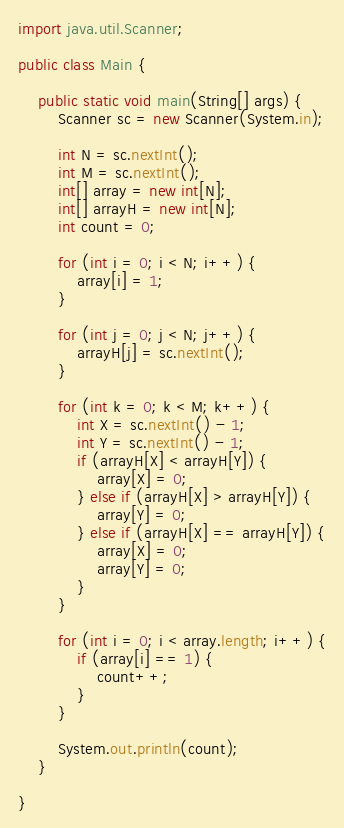<code> <loc_0><loc_0><loc_500><loc_500><_Java_>import java.util.Scanner;

public class Main {

	public static void main(String[] args) {
		Scanner sc = new Scanner(System.in);

		int N = sc.nextInt();
		int M = sc.nextInt();
		int[] array = new int[N];
		int[] arrayH = new int[N];
		int count = 0;

		for (int i = 0; i < N; i++) {
			array[i] = 1;
		}

		for (int j = 0; j < N; j++) {
			arrayH[j] = sc.nextInt();
		}

		for (int k = 0; k < M; k++) {
			int X = sc.nextInt() - 1;
			int Y = sc.nextInt() - 1;
			if (arrayH[X] < arrayH[Y]) {
				array[X] = 0;
			} else if (arrayH[X] > arrayH[Y]) {
				array[Y] = 0;
			} else if (arrayH[X] == arrayH[Y]) {
				array[X] = 0;
				array[Y] = 0;
			}
		}

		for (int i = 0; i < array.length; i++) {
			if (array[i] == 1) {
				count++;
			}
		}

		System.out.println(count);
	}

}</code> 